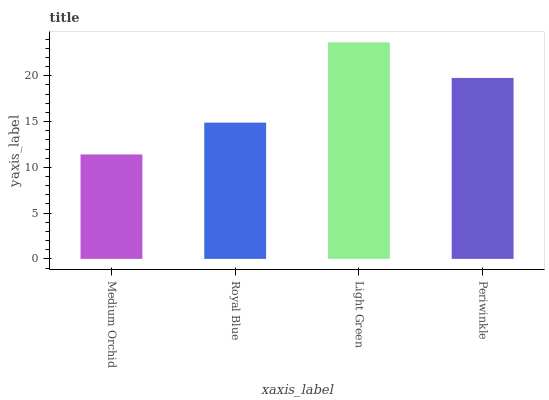Is Medium Orchid the minimum?
Answer yes or no. Yes. Is Light Green the maximum?
Answer yes or no. Yes. Is Royal Blue the minimum?
Answer yes or no. No. Is Royal Blue the maximum?
Answer yes or no. No. Is Royal Blue greater than Medium Orchid?
Answer yes or no. Yes. Is Medium Orchid less than Royal Blue?
Answer yes or no. Yes. Is Medium Orchid greater than Royal Blue?
Answer yes or no. No. Is Royal Blue less than Medium Orchid?
Answer yes or no. No. Is Periwinkle the high median?
Answer yes or no. Yes. Is Royal Blue the low median?
Answer yes or no. Yes. Is Royal Blue the high median?
Answer yes or no. No. Is Medium Orchid the low median?
Answer yes or no. No. 